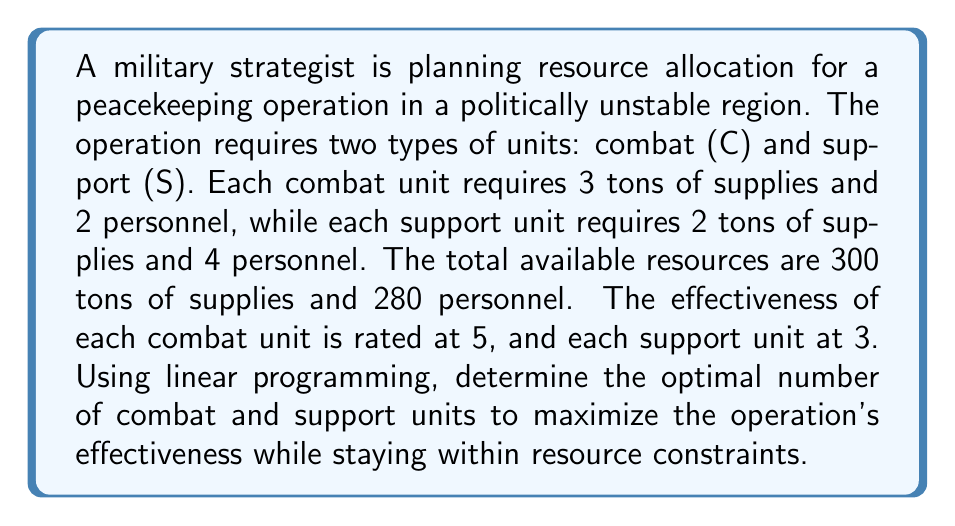Give your solution to this math problem. Let's approach this step-by-step using linear programming:

1. Define variables:
   Let $x$ = number of combat units
   Let $y$ = number of support units

2. Objective function:
   Maximize $Z = 5x + 3y$ (effectiveness)

3. Constraints:
   Supplies: $3x + 2y \leq 300$
   Personnel: $2x + 4y \leq 280$
   Non-negativity: $x \geq 0, y \geq 0$

4. Set up the linear programming problem:
   Maximize $Z = 5x + 3y$
   Subject to:
   $3x + 2y \leq 300$
   $2x + 4y \leq 280$
   $x \geq 0, y \geq 0$

5. Solve using the graphical method:
   a) Plot the constraints:
      For $3x + 2y = 300$: x-intercept (100, 0), y-intercept (0, 150)
      For $2x + 4y = 280$: x-intercept (140, 0), y-intercept (0, 70)

   b) Identify the feasible region (the area satisfying all constraints)

   c) Find the corner points of the feasible region:
      (0, 0), (0, 70), (100, 0), and the intersection of the two constraint lines

   d) To find the intersection point, solve:
      $3x + 2y = 300$
      $2x + 4y = 280$
      Subtracting the second equation from the first:
      $x - 2y = 20$
      $x = 20 + 2y$
      Substituting into the first equation:
      $3(20 + 2y) + 2y = 300$
      $60 + 6y + 2y = 300$
      $8y = 240$
      $y = 30$
      $x = 20 + 2(30) = 80$
      Intersection point: (80, 30)

   e) Evaluate the objective function at each corner point:
      (0, 0): $Z = 0$
      (0, 70): $Z = 3(70) = 210$
      (100, 0): $Z = 5(100) = 500$
      (80, 30): $Z = 5(80) + 3(30) = 490$

6. The maximum value of Z occurs at (80, 30)

Therefore, the optimal allocation is 80 combat units and 30 support units, giving a maximum effectiveness of 490.
Answer: 80 combat units, 30 support units 